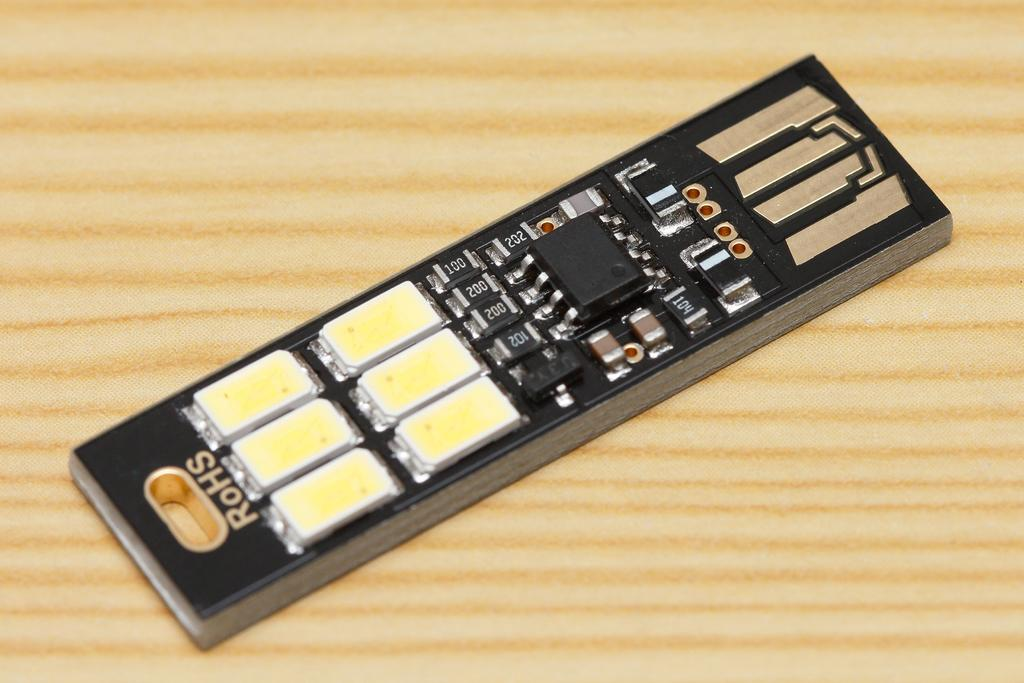Provide a one-sentence caption for the provided image. A black and yellow small electric component made by RoHs. 